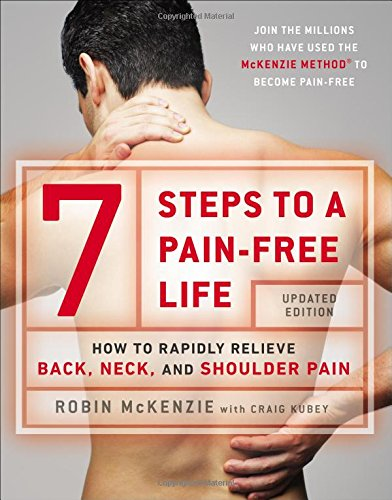What method does this book primarily discuss? The book primarily discusses the McKenzie Method, a technique developed by Robin McKenzie used worldwide to treat musculoskeletal issues, particularly focusing on spine-related conditions. 